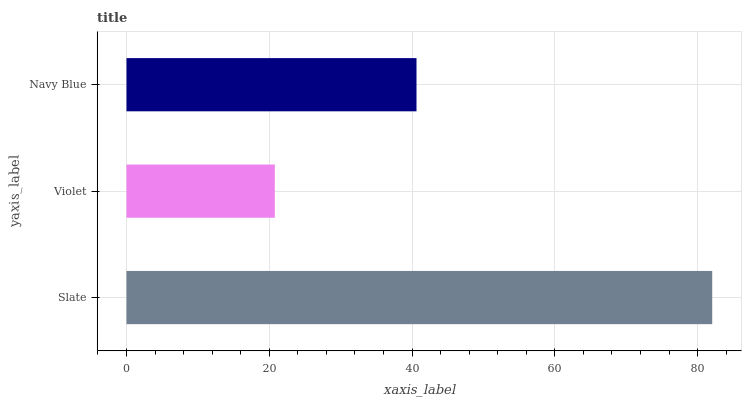Is Violet the minimum?
Answer yes or no. Yes. Is Slate the maximum?
Answer yes or no. Yes. Is Navy Blue the minimum?
Answer yes or no. No. Is Navy Blue the maximum?
Answer yes or no. No. Is Navy Blue greater than Violet?
Answer yes or no. Yes. Is Violet less than Navy Blue?
Answer yes or no. Yes. Is Violet greater than Navy Blue?
Answer yes or no. No. Is Navy Blue less than Violet?
Answer yes or no. No. Is Navy Blue the high median?
Answer yes or no. Yes. Is Navy Blue the low median?
Answer yes or no. Yes. Is Violet the high median?
Answer yes or no. No. Is Violet the low median?
Answer yes or no. No. 